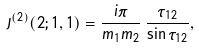<formula> <loc_0><loc_0><loc_500><loc_500>J ^ { ( 2 ) } ( 2 ; 1 , 1 ) = \frac { i \pi } { m _ { 1 } m _ { 2 } } \, \frac { \tau _ { 1 2 } } { \sin \tau _ { 1 2 } } ,</formula> 